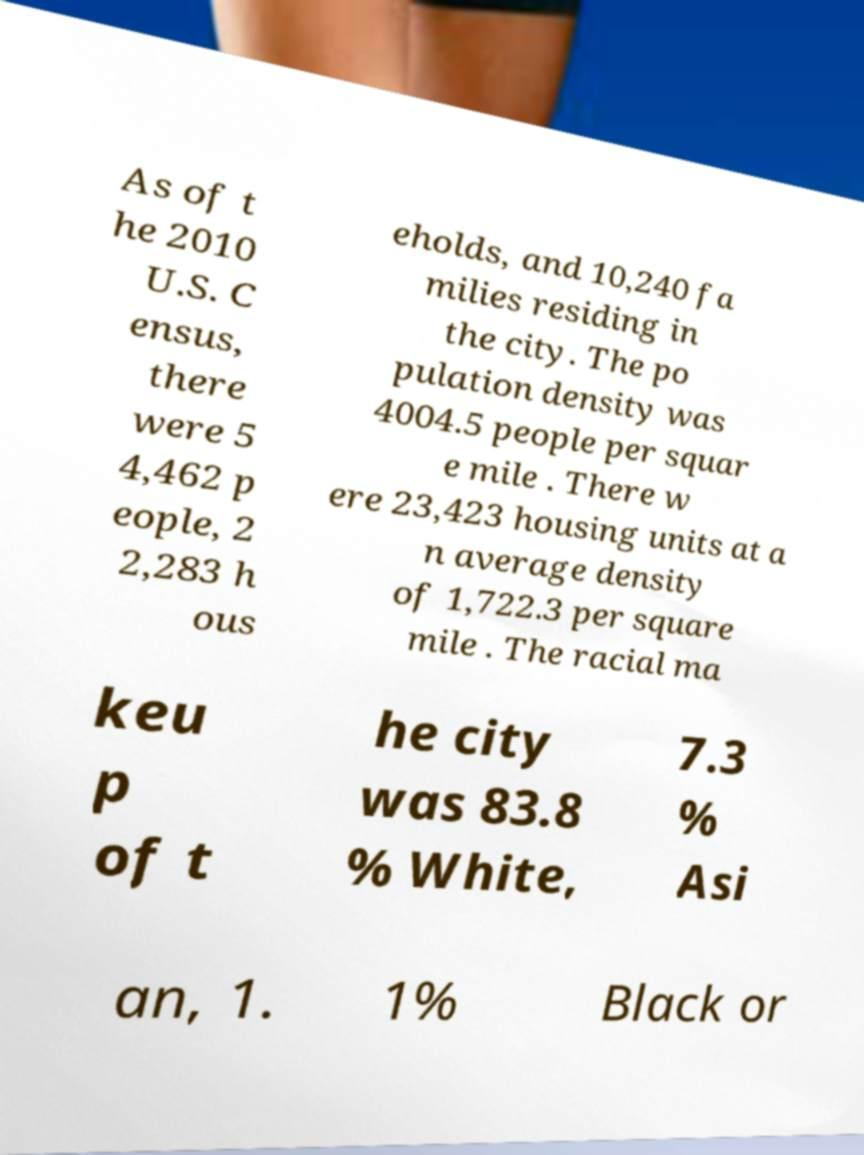Could you assist in decoding the text presented in this image and type it out clearly? As of t he 2010 U.S. C ensus, there were 5 4,462 p eople, 2 2,283 h ous eholds, and 10,240 fa milies residing in the city. The po pulation density was 4004.5 people per squar e mile . There w ere 23,423 housing units at a n average density of 1,722.3 per square mile . The racial ma keu p of t he city was 83.8 % White, 7.3 % Asi an, 1. 1% Black or 